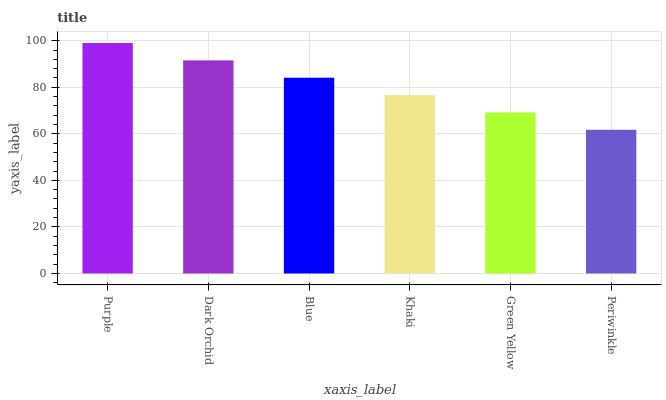Is Periwinkle the minimum?
Answer yes or no. Yes. Is Purple the maximum?
Answer yes or no. Yes. Is Dark Orchid the minimum?
Answer yes or no. No. Is Dark Orchid the maximum?
Answer yes or no. No. Is Purple greater than Dark Orchid?
Answer yes or no. Yes. Is Dark Orchid less than Purple?
Answer yes or no. Yes. Is Dark Orchid greater than Purple?
Answer yes or no. No. Is Purple less than Dark Orchid?
Answer yes or no. No. Is Blue the high median?
Answer yes or no. Yes. Is Khaki the low median?
Answer yes or no. Yes. Is Dark Orchid the high median?
Answer yes or no. No. Is Blue the low median?
Answer yes or no. No. 